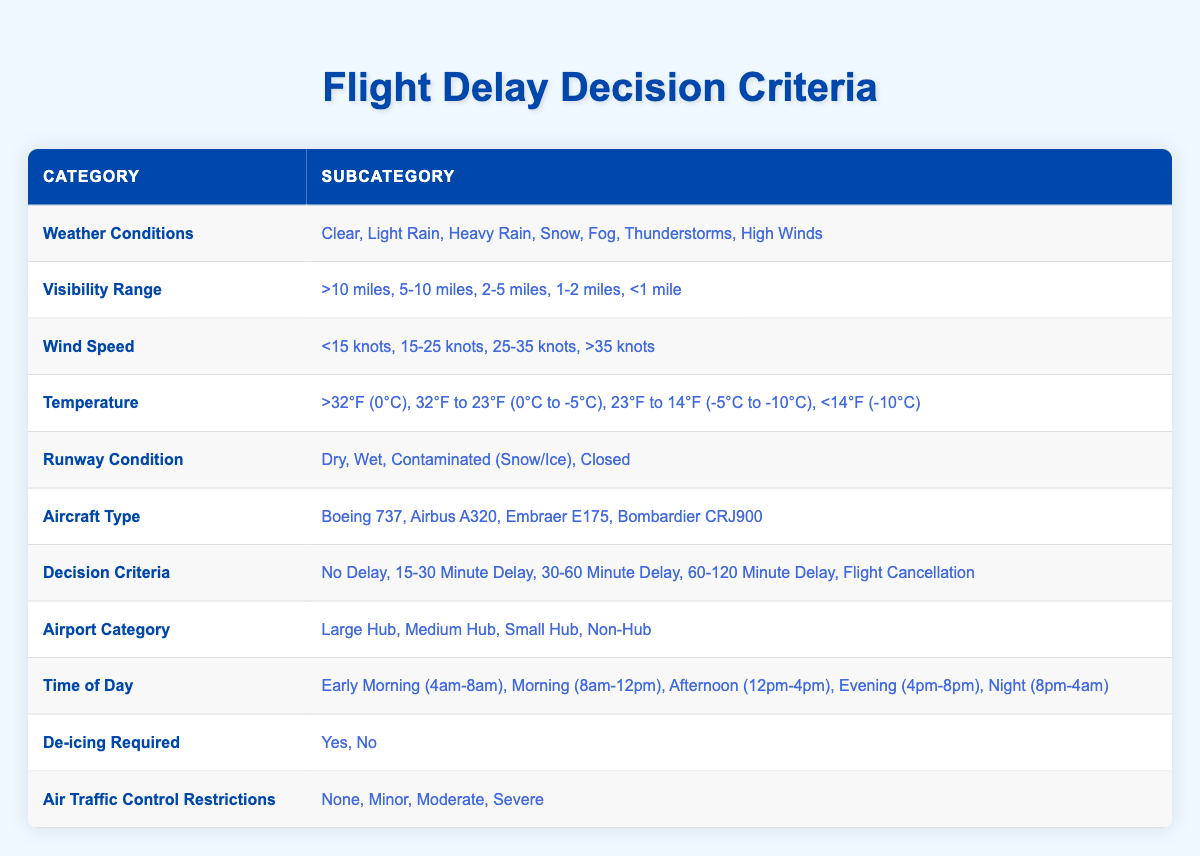What weather conditions are listed in the table? The table includes the following weather conditions: Clear, Light Rain, Heavy Rain, Snow, Fog, Thunderstorms, and High Winds. This information can be retrieved directly from the first category in the table.
Answer: Clear, Light Rain, Heavy Rain, Snow, Fog, Thunderstorms, High Winds What is the range of visibility specified for "Heavy Rain"? The table lists visibility ranges that apply to various weather conditions, but it does not explicitly specify visibility for each condition. To answer this question, we refer to the visibility ranges listed: >10 miles, 5-10 miles, 2-5 miles, 1-2 miles, <1 mile, and conclude that heavy rain typically correlates with a visibility range of 2-5 miles.
Answer: 2-5 miles Is de-icing required when the temperature is below 14°F? According to the data provided, when the temperature is listed as <14°F, de-icing is usually required due to safety concerns. This can be confirmed by the direct linkage of de-icing requirements and temperature conditions in the table, implying a 'Yes' under these circumstances.
Answer: Yes What will be the decision regarding flight delays if the weather condition is "Snow" and runway condition is "Contaminated (Snow/Ice)"? To answer this question, we need to consider both the weather and runway conditions directly. Typically, "Snow" combined with a "Contaminated (Snow/Ice)" runway would lead to significant delays. Therefore, without the specific decision criteria that correlate directly to this combination in the table, it is reasonable to infer the likelihood of a significant delay. Based on experience, such conditions likely lead to a decision of 30-60 Minute Delay.
Answer: 30-60 Minute Delay What is the decision criteria when visibility is less than 1 mile and there are high winds? This scenario necessitates cross-referencing visibility less than 1 mile and the high winds category. Such conditions often heighten safety concerns, resulting in delays or cancellations. The combination usually leads to significant flight operational challenges, likely resulting in a Flight Cancellation due to severe restrictions.
Answer: Flight Cancellation What average delay time would one expect if wind speeds are between 15-25 knots and visibility is between 2-5 miles? To determine the average, we need to think about the delays implied by the range of conditions. Delays for 15-25 knots and 2-5 miles visibility usually expect moderate disruptions, hence if we consider the potential delay outcomes (15-30 minutes, 30-60 minutes) on average, we could reason that it will fall between these categories. By conceptual averaging, 15-30 Minute Delay and 30-60 Minute Delay could lead to an estimated average of approximately 45 minutes considering impending average values across possible scenarios.
Answer: 45 minutes Are flight cancellations more likely at night compared to early morning? Comparing the decision table for time of day and considering typical air traffic and weather conditions—the night could have increased chances of cancellations due to reduced operational capacity and increased probabilities of adverse weather, while early morning flights often have less congested airspace and better conditions. Hence, based on observational trends, it can be concluded that cancellations are indeed comparatively more probable during the night.
Answer: Yes 